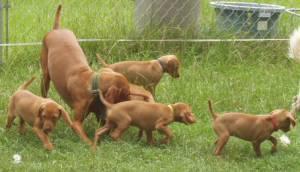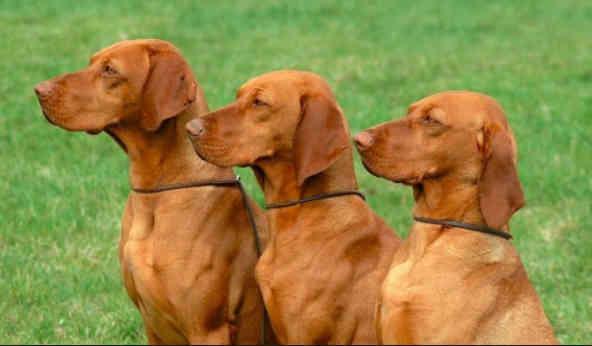The first image is the image on the left, the second image is the image on the right. For the images displayed, is the sentence "There are only two dogs." factually correct? Answer yes or no. No. The first image is the image on the left, the second image is the image on the right. For the images displayed, is the sentence "One image shows a dog running toward the camera, and the other image shows a dog in a still position gazing rightward." factually correct? Answer yes or no. No. 